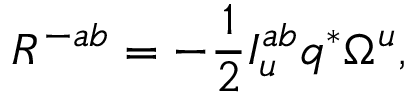<formula> <loc_0><loc_0><loc_500><loc_500>R ^ { - a b } = - { \frac { 1 } { 2 } } I _ { u } ^ { a b } q ^ { * } \Omega ^ { u } ,</formula> 